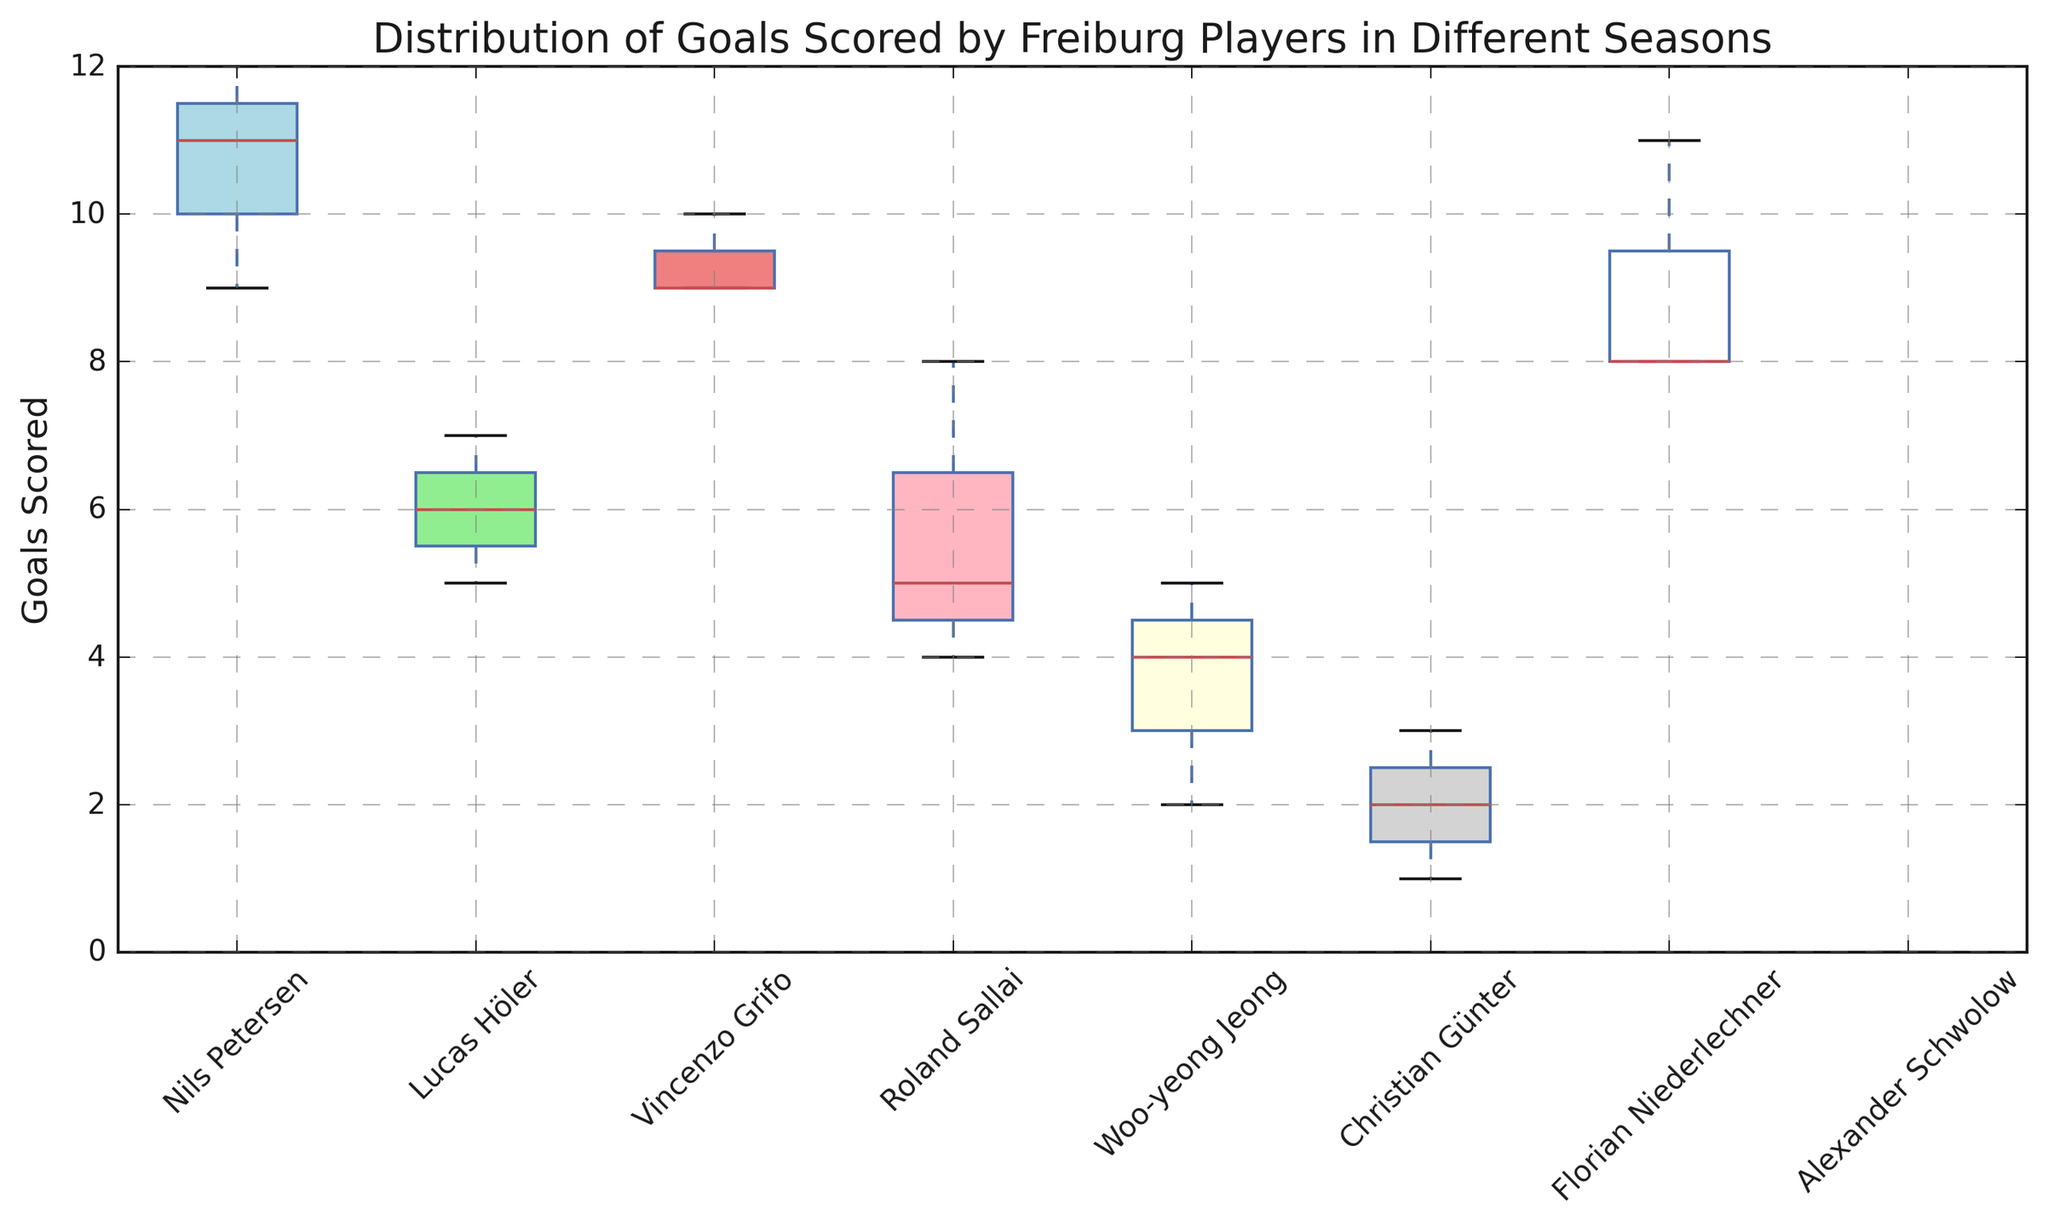What is the median number of goals scored by Nils Petersen across the seasons? To find the median, list the goals scored by Nils Petersen in ascending order: (9, 11, 12). The middle value in this ordered list is 11.
Answer: 11 Which player has the widest range of goals scored? The range is calculated as the difference between the maximum and minimum values within each player’s box plot. Nils Petersen has the widest range (12 - 9 = 3).
Answer: Nils Petersen What color represents the box plot for Lucas Höler? Each player's box plot is represented by a specific color. The box plot for Lucas Höler is color-coded in light green.
Answer: Light green Between Roland Sallai and Woo-yeong Jeong, who has a higher median number of goals? The median number of goals is represented by the line inside the box. Roland Sallai’s median is 5, whereas Woo-yeong Jeong’s median is 4.
Answer: Roland Sallai What is the interquartile range (IQR) for Vincenzo Grifo? The interquartile range (IQR) is the difference between the 75th percentile and the 25th percentile. For Vincenzo Grifo, the IQR is (10 - 9).
Answer: 1 Compare the median goals scored by Nils Petersen and Christian Günter. Which player has a higher median and by how much? The median number of goals scored by Nils Petersen is 11 and by Christian Günter is 2. The difference is (11 - 2).
Answer: Nils Petersen, by 9 goals Which player has the lowest overall number of goals scored based on the box plot? Look for the lowest point in all the box plots. Christian Günter has the lowest overall number of goals scored with a minimum of 1 goal.
Answer: Christian Günter For which player are the goals most spread out? The spread can be assessed by looking at the length of the box and whiskers. Nils Petersen has the most spread-out number of goals as his plot has larger whiskers and IQR.
Answer: Nils Petersen Determine the average number of goals scored by Florian Niederlechner across the seasons. Sum the goals scored by Florian Niederlechner (8 + 8 + 11 = 27) and divide by the number of seasons (3), which gives 27/3.
Answer: 9 